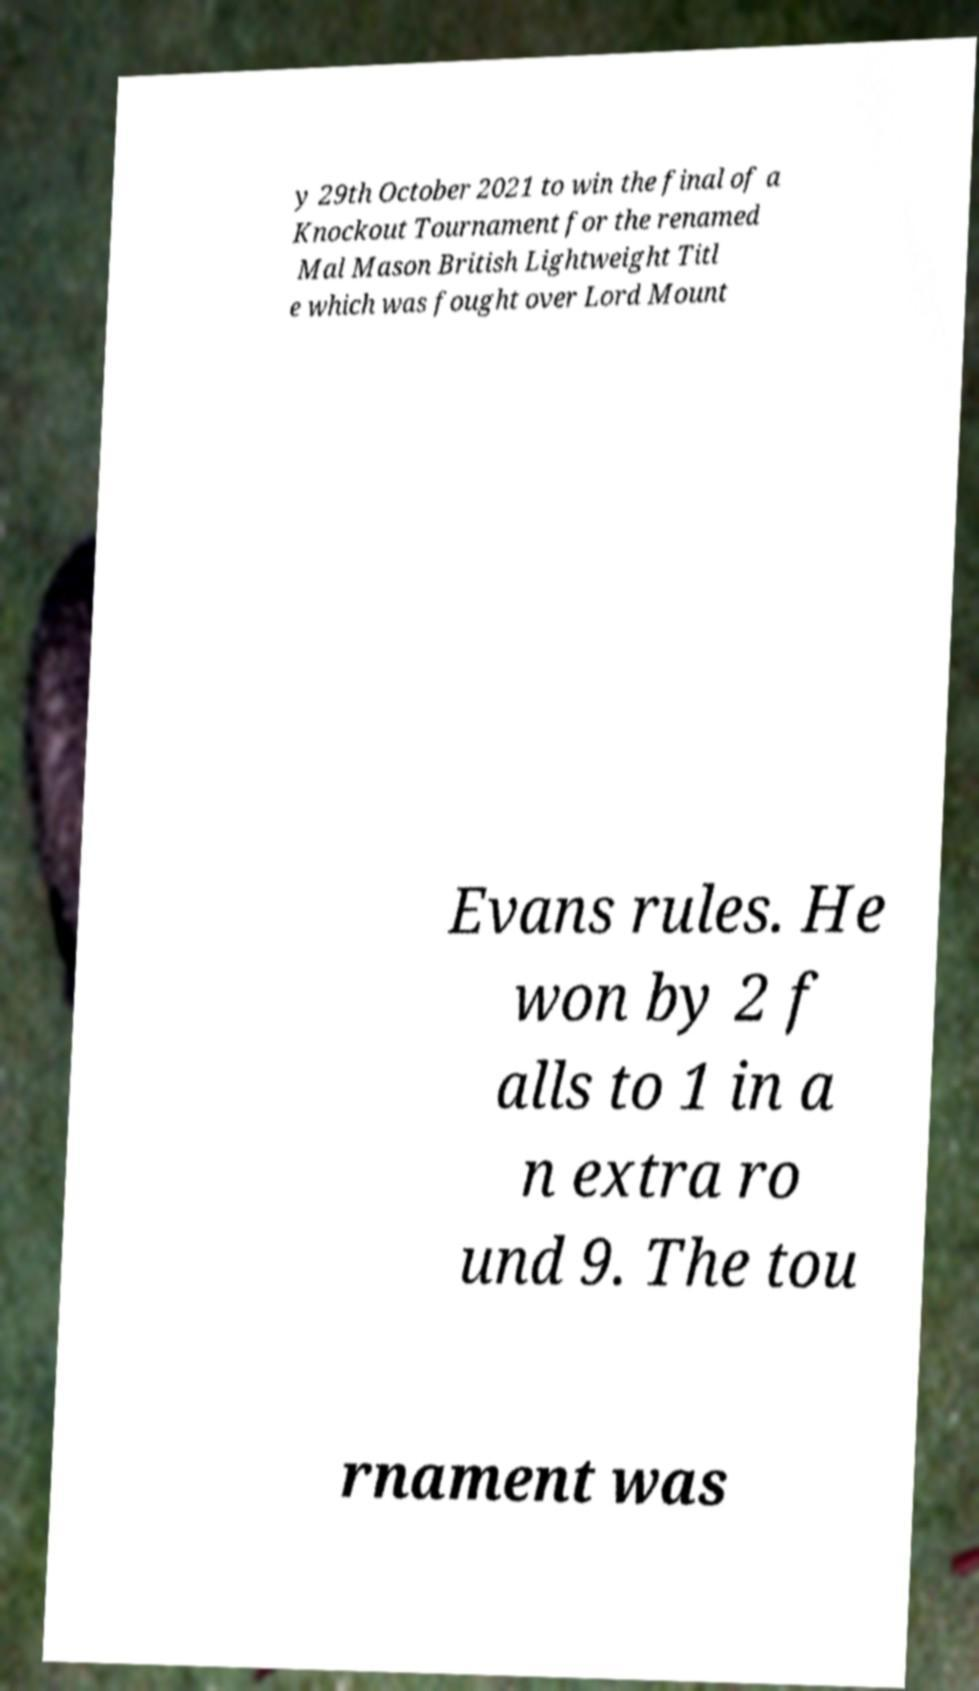What messages or text are displayed in this image? I need them in a readable, typed format. y 29th October 2021 to win the final of a Knockout Tournament for the renamed Mal Mason British Lightweight Titl e which was fought over Lord Mount Evans rules. He won by 2 f alls to 1 in a n extra ro und 9. The tou rnament was 